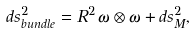Convert formula to latex. <formula><loc_0><loc_0><loc_500><loc_500>d s ^ { 2 } _ { b u n d l e } = R ^ { 2 } \, \omega \otimes \omega + d s ^ { 2 } _ { M } ,</formula> 